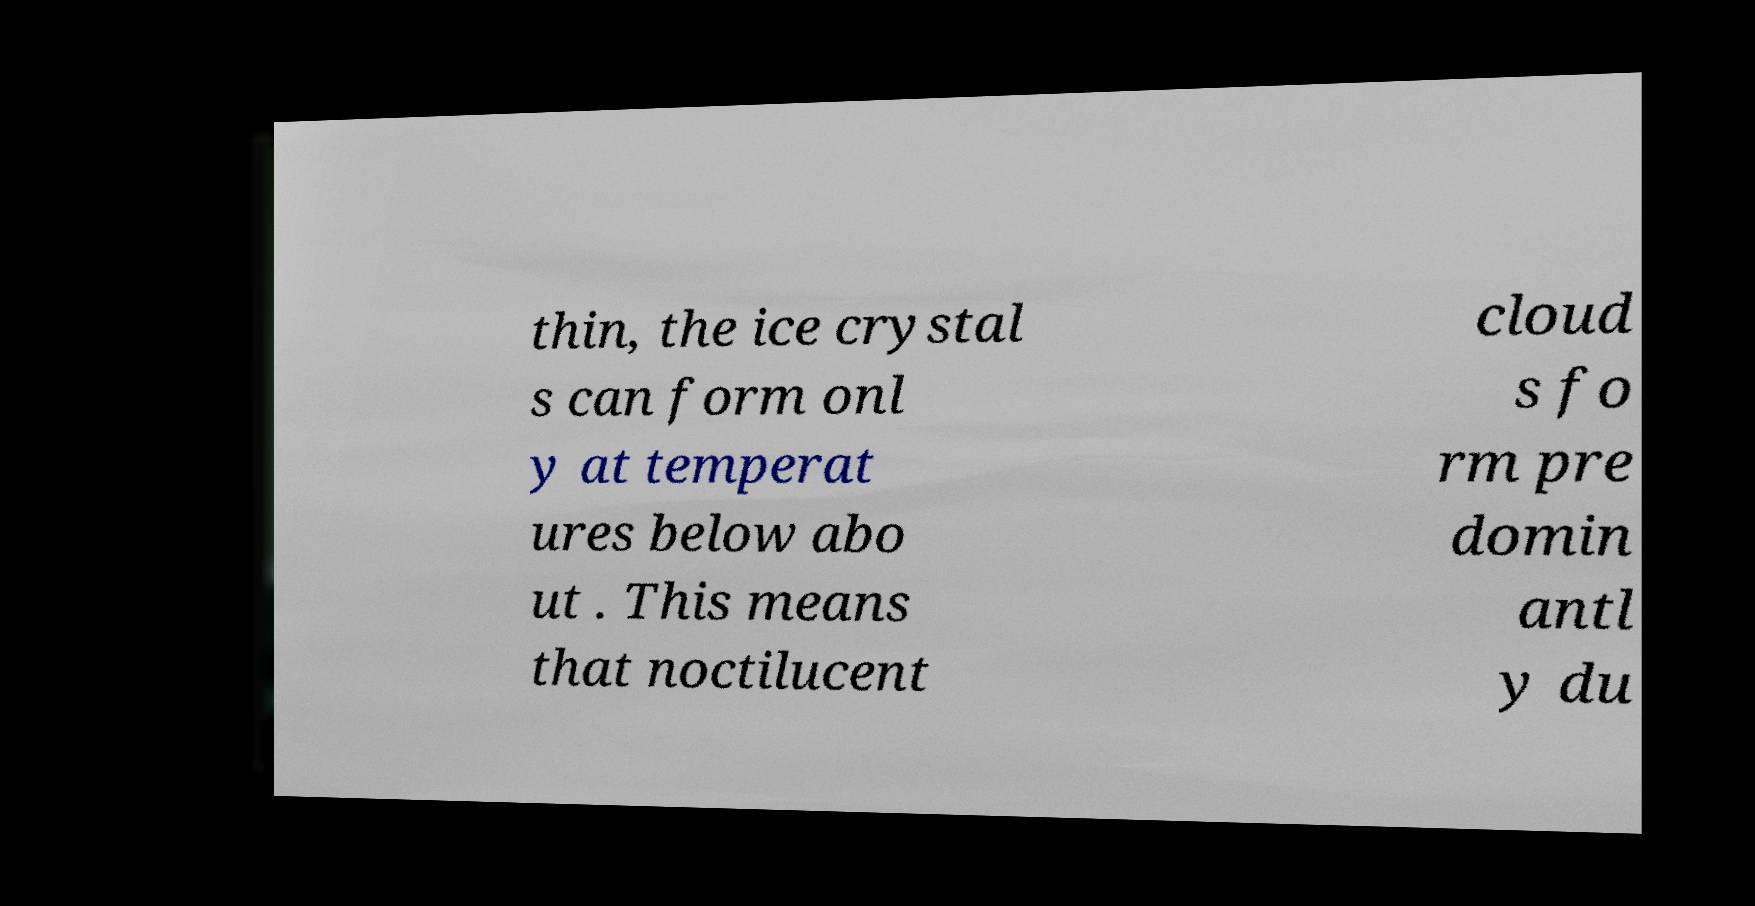Could you extract and type out the text from this image? thin, the ice crystal s can form onl y at temperat ures below abo ut . This means that noctilucent cloud s fo rm pre domin antl y du 